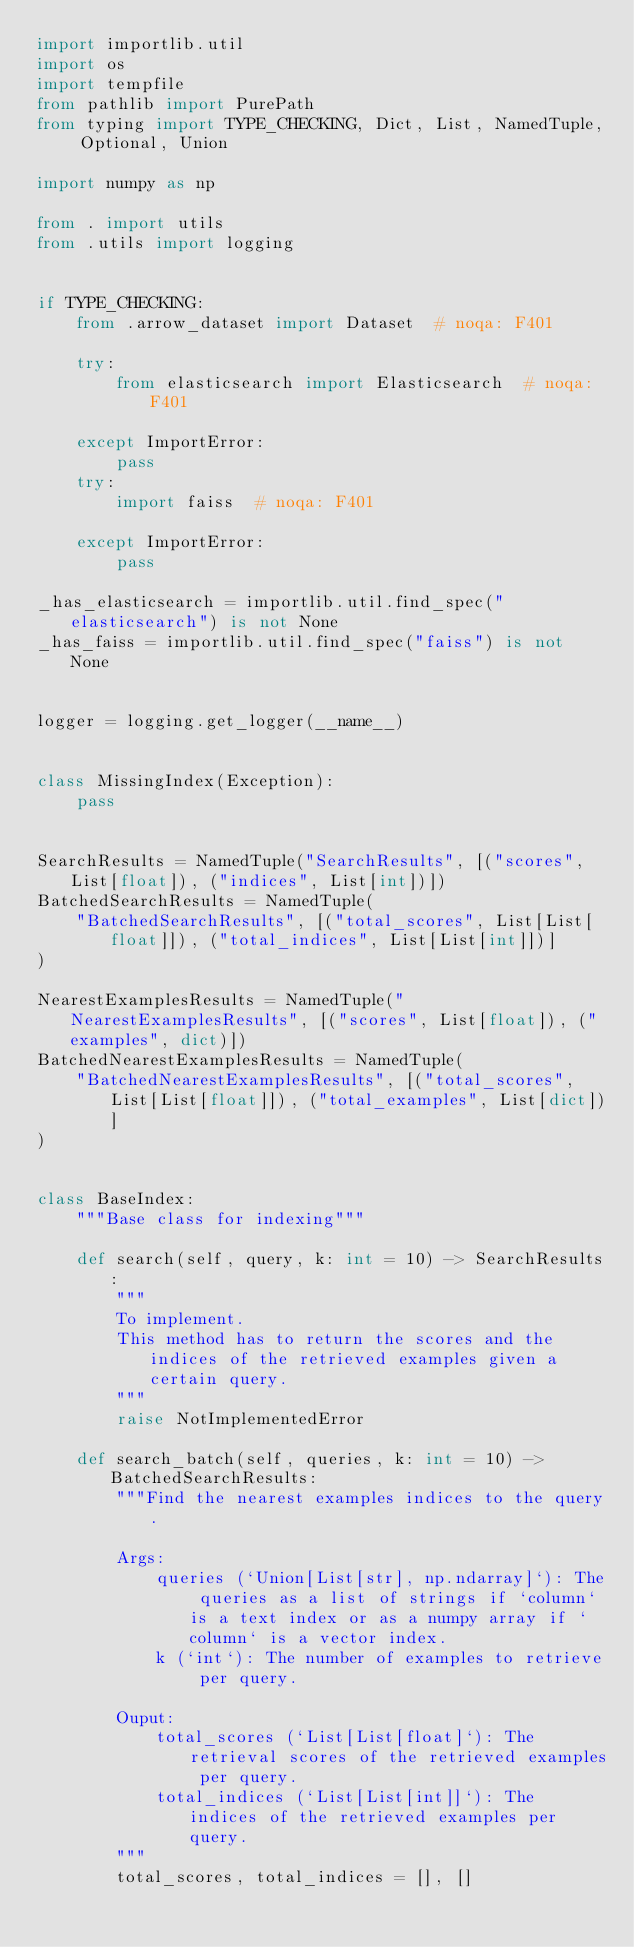Convert code to text. <code><loc_0><loc_0><loc_500><loc_500><_Python_>import importlib.util
import os
import tempfile
from pathlib import PurePath
from typing import TYPE_CHECKING, Dict, List, NamedTuple, Optional, Union

import numpy as np

from . import utils
from .utils import logging


if TYPE_CHECKING:
    from .arrow_dataset import Dataset  # noqa: F401

    try:
        from elasticsearch import Elasticsearch  # noqa: F401

    except ImportError:
        pass
    try:
        import faiss  # noqa: F401

    except ImportError:
        pass

_has_elasticsearch = importlib.util.find_spec("elasticsearch") is not None
_has_faiss = importlib.util.find_spec("faiss") is not None


logger = logging.get_logger(__name__)


class MissingIndex(Exception):
    pass


SearchResults = NamedTuple("SearchResults", [("scores", List[float]), ("indices", List[int])])
BatchedSearchResults = NamedTuple(
    "BatchedSearchResults", [("total_scores", List[List[float]]), ("total_indices", List[List[int]])]
)

NearestExamplesResults = NamedTuple("NearestExamplesResults", [("scores", List[float]), ("examples", dict)])
BatchedNearestExamplesResults = NamedTuple(
    "BatchedNearestExamplesResults", [("total_scores", List[List[float]]), ("total_examples", List[dict])]
)


class BaseIndex:
    """Base class for indexing"""

    def search(self, query, k: int = 10) -> SearchResults:
        """
        To implement.
        This method has to return the scores and the indices of the retrieved examples given a certain query.
        """
        raise NotImplementedError

    def search_batch(self, queries, k: int = 10) -> BatchedSearchResults:
        """Find the nearest examples indices to the query.

        Args:
            queries (`Union[List[str], np.ndarray]`): The queries as a list of strings if `column` is a text index or as a numpy array if `column` is a vector index.
            k (`int`): The number of examples to retrieve per query.

        Ouput:
            total_scores (`List[List[float]`): The retrieval scores of the retrieved examples per query.
            total_indices (`List[List[int]]`): The indices of the retrieved examples per query.
        """
        total_scores, total_indices = [], []</code> 